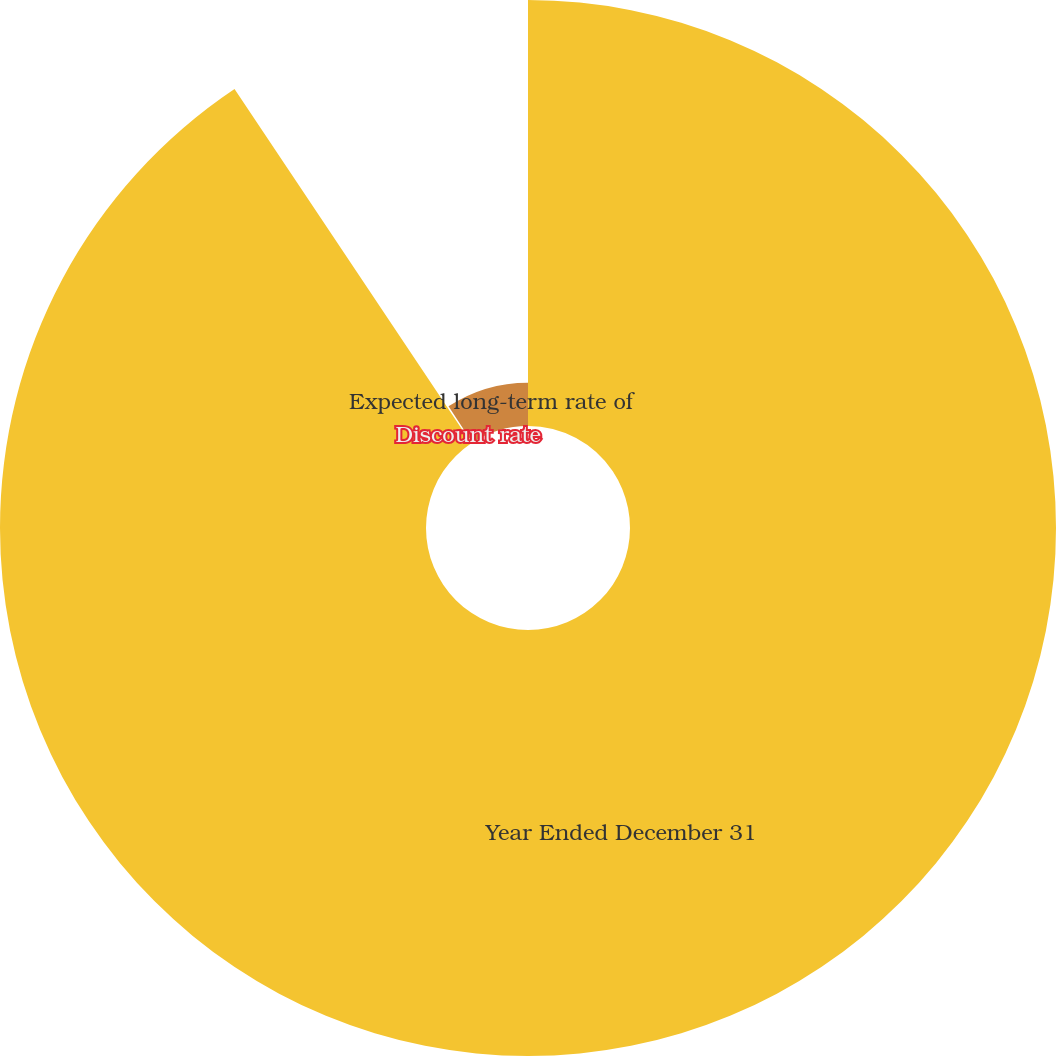Convert chart. <chart><loc_0><loc_0><loc_500><loc_500><pie_chart><fcel>Year Ended December 31<fcel>Discount rate<fcel>Expected long-term rate of<nl><fcel>90.62%<fcel>0.17%<fcel>9.21%<nl></chart> 